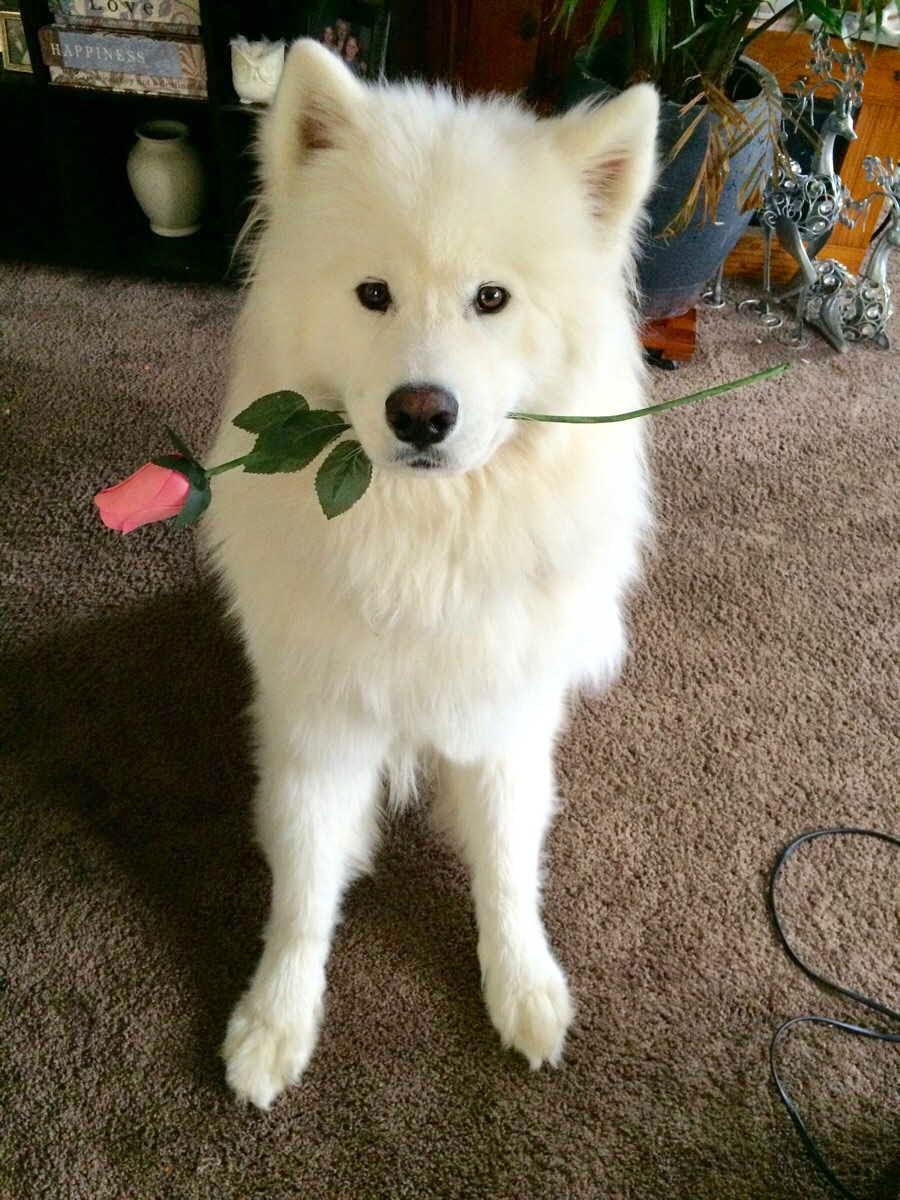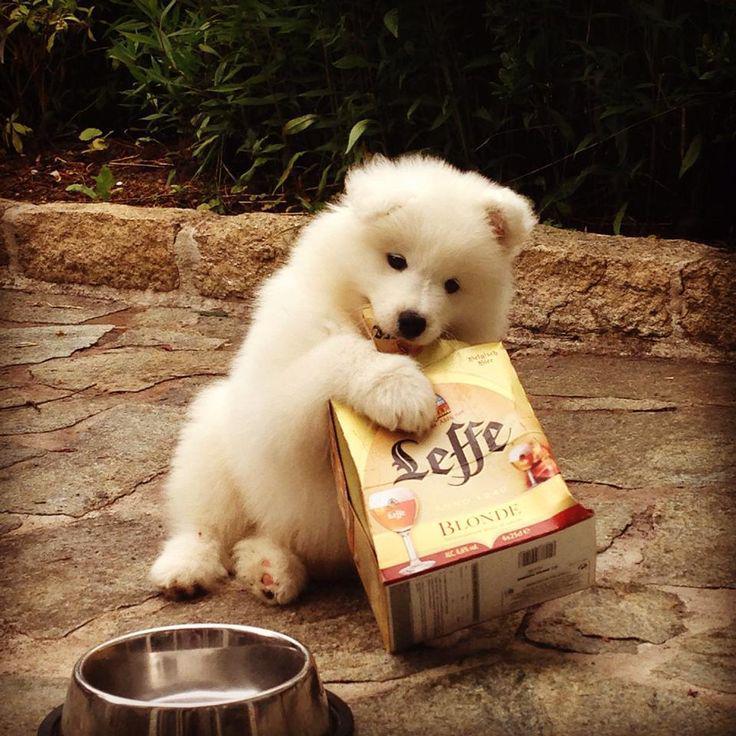The first image is the image on the left, the second image is the image on the right. Examine the images to the left and right. Is the description "there are two dogs in the image pair" accurate? Answer yes or no. Yes. The first image is the image on the left, the second image is the image on the right. Given the left and right images, does the statement "There are two dogs." hold true? Answer yes or no. Yes. 